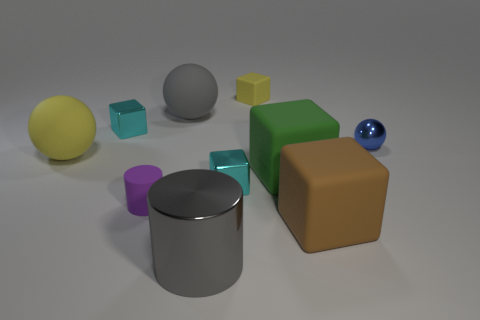Subtract all cyan blocks. How many were subtracted if there are1cyan blocks left? 1 Subtract all brown rubber cubes. How many cubes are left? 4 Subtract all brown cubes. How many cubes are left? 4 Subtract all gray cubes. Subtract all red balls. How many cubes are left? 5 Subtract all cylinders. How many objects are left? 8 Subtract all big yellow matte cubes. Subtract all brown cubes. How many objects are left? 9 Add 8 purple matte cylinders. How many purple matte cylinders are left? 9 Add 6 gray metal cylinders. How many gray metal cylinders exist? 7 Subtract 0 red balls. How many objects are left? 10 